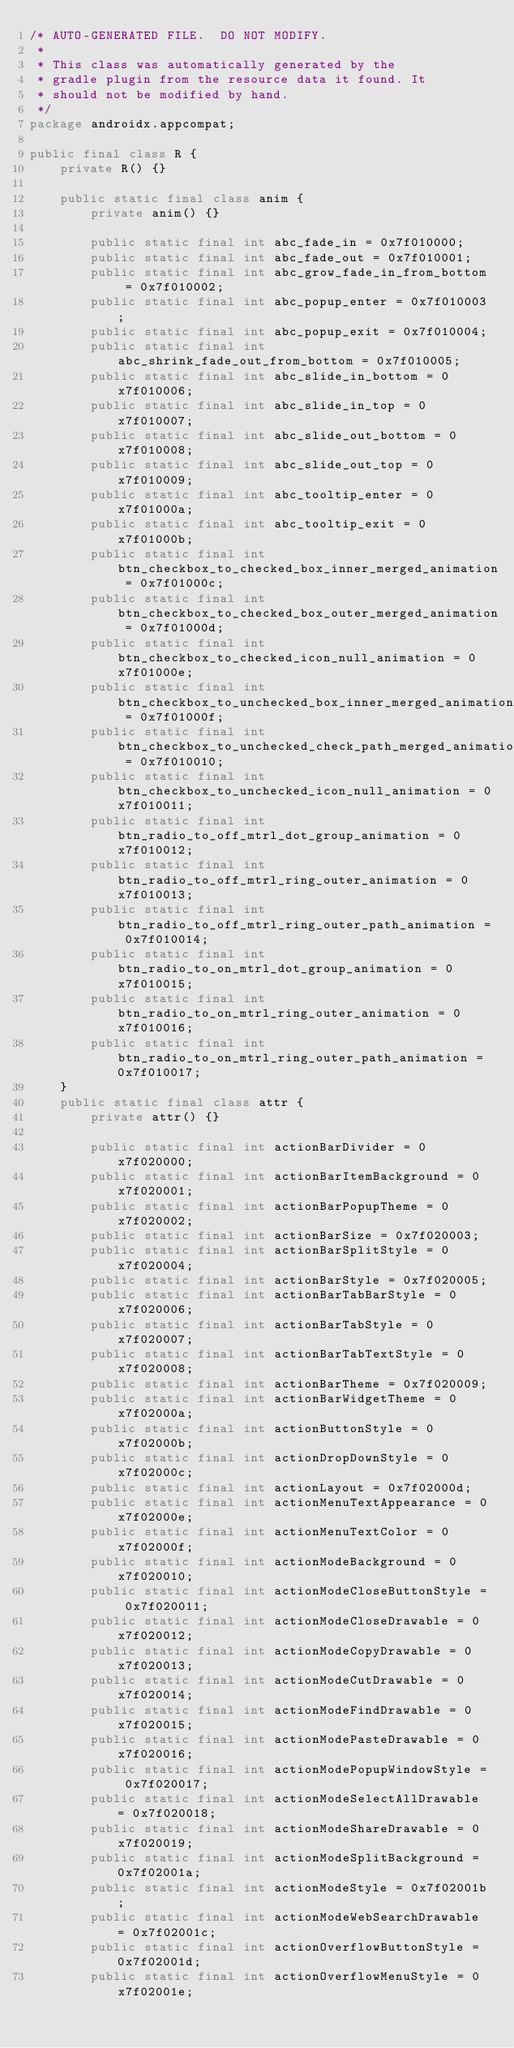Convert code to text. <code><loc_0><loc_0><loc_500><loc_500><_Java_>/* AUTO-GENERATED FILE.  DO NOT MODIFY.
 *
 * This class was automatically generated by the
 * gradle plugin from the resource data it found. It
 * should not be modified by hand.
 */
package androidx.appcompat;

public final class R {
    private R() {}

    public static final class anim {
        private anim() {}

        public static final int abc_fade_in = 0x7f010000;
        public static final int abc_fade_out = 0x7f010001;
        public static final int abc_grow_fade_in_from_bottom = 0x7f010002;
        public static final int abc_popup_enter = 0x7f010003;
        public static final int abc_popup_exit = 0x7f010004;
        public static final int abc_shrink_fade_out_from_bottom = 0x7f010005;
        public static final int abc_slide_in_bottom = 0x7f010006;
        public static final int abc_slide_in_top = 0x7f010007;
        public static final int abc_slide_out_bottom = 0x7f010008;
        public static final int abc_slide_out_top = 0x7f010009;
        public static final int abc_tooltip_enter = 0x7f01000a;
        public static final int abc_tooltip_exit = 0x7f01000b;
        public static final int btn_checkbox_to_checked_box_inner_merged_animation = 0x7f01000c;
        public static final int btn_checkbox_to_checked_box_outer_merged_animation = 0x7f01000d;
        public static final int btn_checkbox_to_checked_icon_null_animation = 0x7f01000e;
        public static final int btn_checkbox_to_unchecked_box_inner_merged_animation = 0x7f01000f;
        public static final int btn_checkbox_to_unchecked_check_path_merged_animation = 0x7f010010;
        public static final int btn_checkbox_to_unchecked_icon_null_animation = 0x7f010011;
        public static final int btn_radio_to_off_mtrl_dot_group_animation = 0x7f010012;
        public static final int btn_radio_to_off_mtrl_ring_outer_animation = 0x7f010013;
        public static final int btn_radio_to_off_mtrl_ring_outer_path_animation = 0x7f010014;
        public static final int btn_radio_to_on_mtrl_dot_group_animation = 0x7f010015;
        public static final int btn_radio_to_on_mtrl_ring_outer_animation = 0x7f010016;
        public static final int btn_radio_to_on_mtrl_ring_outer_path_animation = 0x7f010017;
    }
    public static final class attr {
        private attr() {}

        public static final int actionBarDivider = 0x7f020000;
        public static final int actionBarItemBackground = 0x7f020001;
        public static final int actionBarPopupTheme = 0x7f020002;
        public static final int actionBarSize = 0x7f020003;
        public static final int actionBarSplitStyle = 0x7f020004;
        public static final int actionBarStyle = 0x7f020005;
        public static final int actionBarTabBarStyle = 0x7f020006;
        public static final int actionBarTabStyle = 0x7f020007;
        public static final int actionBarTabTextStyle = 0x7f020008;
        public static final int actionBarTheme = 0x7f020009;
        public static final int actionBarWidgetTheme = 0x7f02000a;
        public static final int actionButtonStyle = 0x7f02000b;
        public static final int actionDropDownStyle = 0x7f02000c;
        public static final int actionLayout = 0x7f02000d;
        public static final int actionMenuTextAppearance = 0x7f02000e;
        public static final int actionMenuTextColor = 0x7f02000f;
        public static final int actionModeBackground = 0x7f020010;
        public static final int actionModeCloseButtonStyle = 0x7f020011;
        public static final int actionModeCloseDrawable = 0x7f020012;
        public static final int actionModeCopyDrawable = 0x7f020013;
        public static final int actionModeCutDrawable = 0x7f020014;
        public static final int actionModeFindDrawable = 0x7f020015;
        public static final int actionModePasteDrawable = 0x7f020016;
        public static final int actionModePopupWindowStyle = 0x7f020017;
        public static final int actionModeSelectAllDrawable = 0x7f020018;
        public static final int actionModeShareDrawable = 0x7f020019;
        public static final int actionModeSplitBackground = 0x7f02001a;
        public static final int actionModeStyle = 0x7f02001b;
        public static final int actionModeWebSearchDrawable = 0x7f02001c;
        public static final int actionOverflowButtonStyle = 0x7f02001d;
        public static final int actionOverflowMenuStyle = 0x7f02001e;</code> 